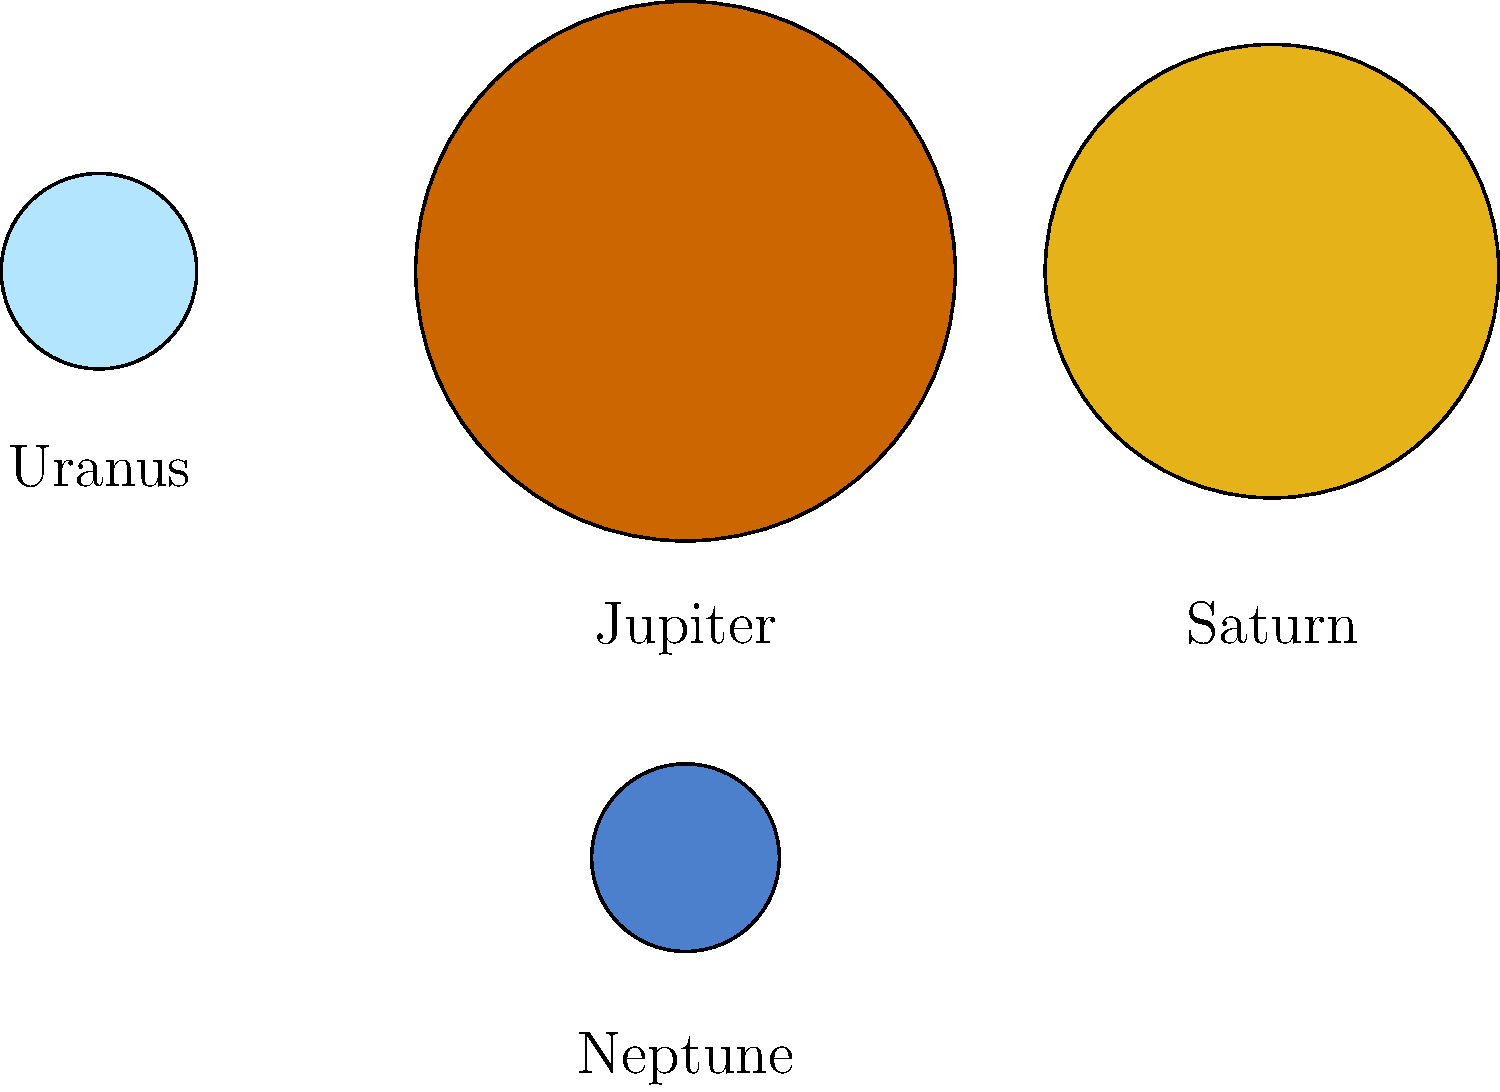In this cosmic lineup of gas giants, which planet's size would make Gwen Stefani exclaim "Don't Speak" in awe of its magnitude? Let's break this down step-by-step:

1. The image shows four planets represented as circles: Jupiter, Saturn, Uranus, and Neptune.

2. These are the four gas giants in our solar system, known for their large sizes compared to the terrestrial planets.

3. The sizes of the circles are proportional to the actual sizes of the planets:
   - Jupiter's circle is the largest
   - Saturn's circle is slightly smaller than Jupiter's
   - Uranus and Neptune are represented by much smaller circles of similar size

4. In reality:
   - Jupiter's diameter is about 139,820 km
   - Saturn's diameter is about 116,460 km
   - Uranus' diameter is about 50,724 km
   - Neptune's diameter is about 49,244 km

5. Jupiter is clearly the largest planet, significantly larger than the others.

6. The question asks which planet would inspire awe due to its size, referencing No Doubt's hit song "Don't Speak".

7. Given its status as the largest planet in our solar system, Jupiter would be the most likely to inspire such a reaction.
Answer: Jupiter 